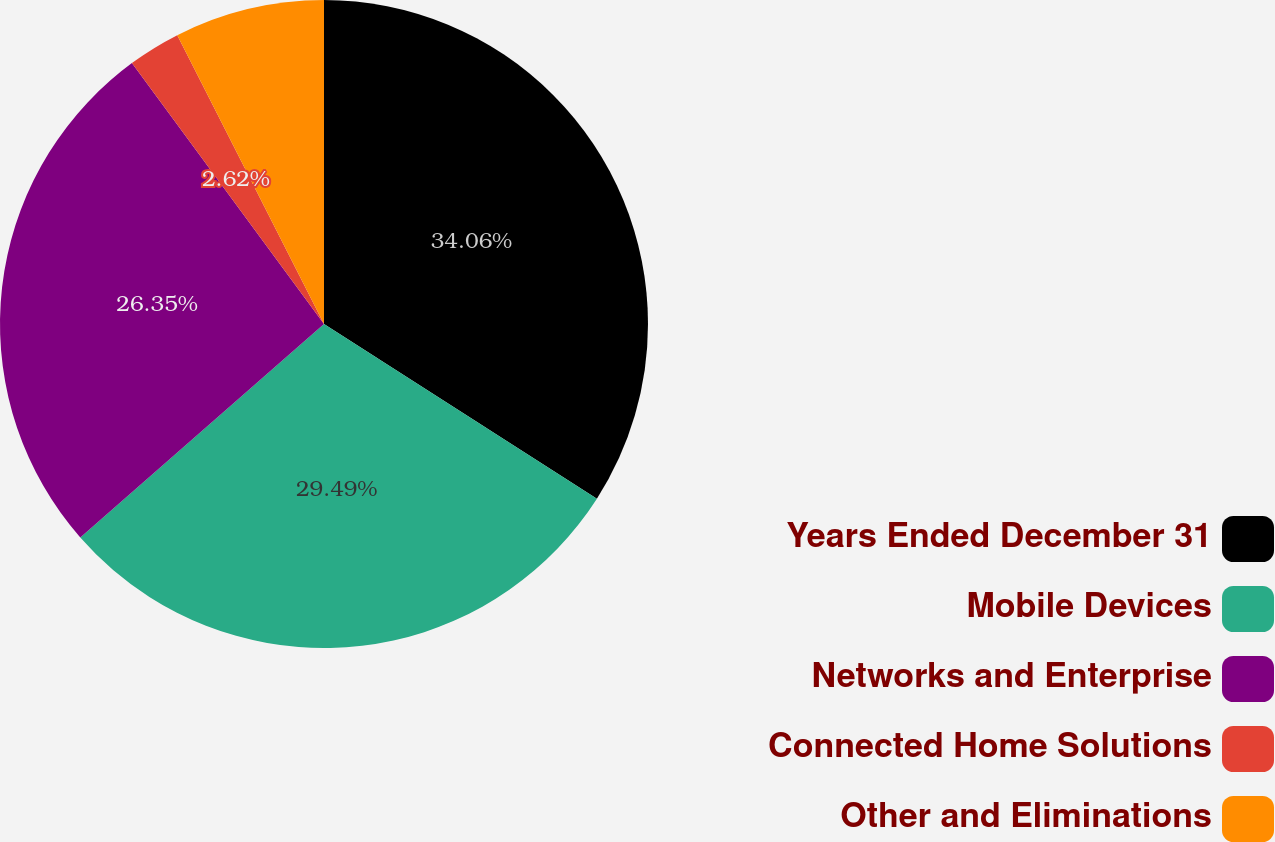<chart> <loc_0><loc_0><loc_500><loc_500><pie_chart><fcel>Years Ended December 31<fcel>Mobile Devices<fcel>Networks and Enterprise<fcel>Connected Home Solutions<fcel>Other and Eliminations<nl><fcel>34.06%<fcel>29.49%<fcel>26.35%<fcel>2.62%<fcel>7.48%<nl></chart> 